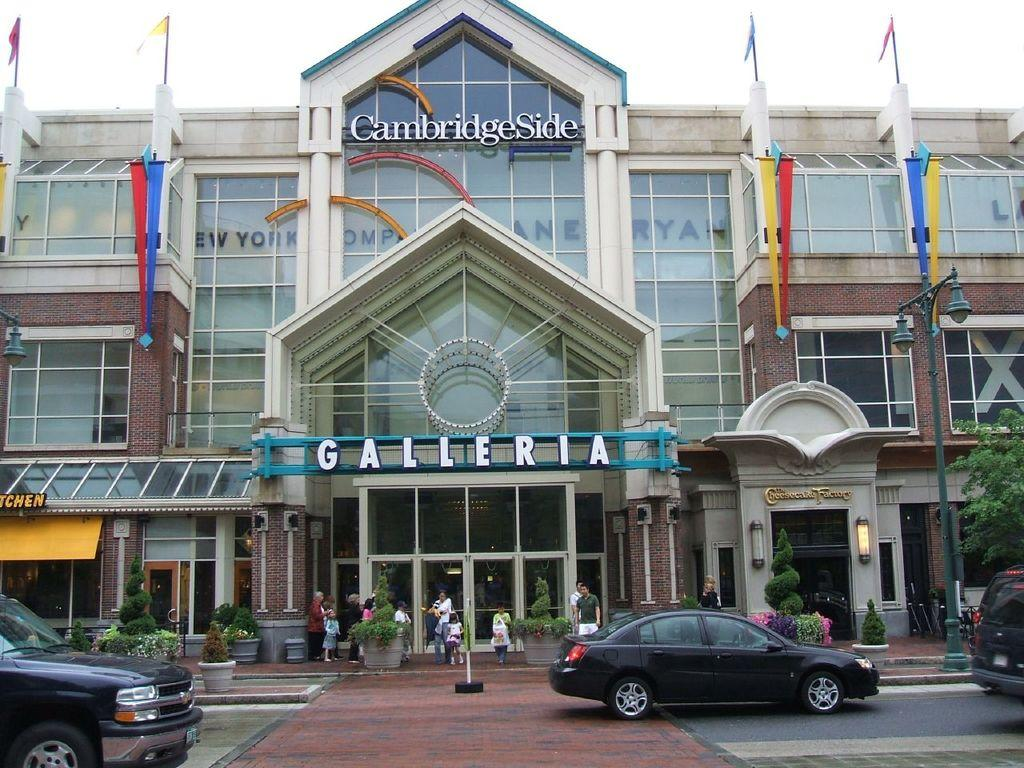What type of vehicles can be seen in the image? There are cars in the image. What other elements are present in the image besides cars? There are plants, people, a pole, buildings, and flags in the image. Can you describe the plants in the image? The plants in the image are not specified, but they are present. What is the pole used for in the image? The purpose of the pole in the image is not mentioned, but it is visible. What type of underwear is the person wearing in the image? There is no information about the clothing of the people in the image, so it cannot be determined what type of underwear they might be wearing. 